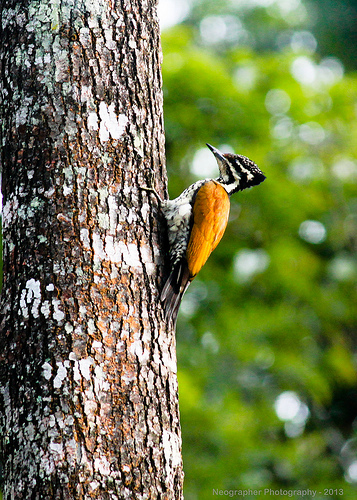Please provide a short description for this region: [0.21, 0.38, 0.48, 0.94]. This large region mainly captures the tree's trunk, adorned with vibrant orange fungus thriving on the moist, shaded bark, adding a colorful contrast. 